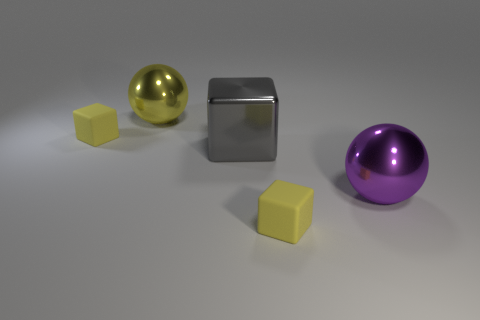Subtract all yellow matte blocks. How many blocks are left? 1 Add 2 balls. How many balls are left? 4 Add 2 big spheres. How many big spheres exist? 4 Add 3 big yellow metal objects. How many objects exist? 8 Subtract all yellow spheres. How many spheres are left? 1 Subtract 0 green blocks. How many objects are left? 5 Subtract all blocks. How many objects are left? 2 Subtract 2 balls. How many balls are left? 0 Subtract all purple blocks. Subtract all purple cylinders. How many blocks are left? 3 Subtract all brown spheres. How many yellow cubes are left? 2 